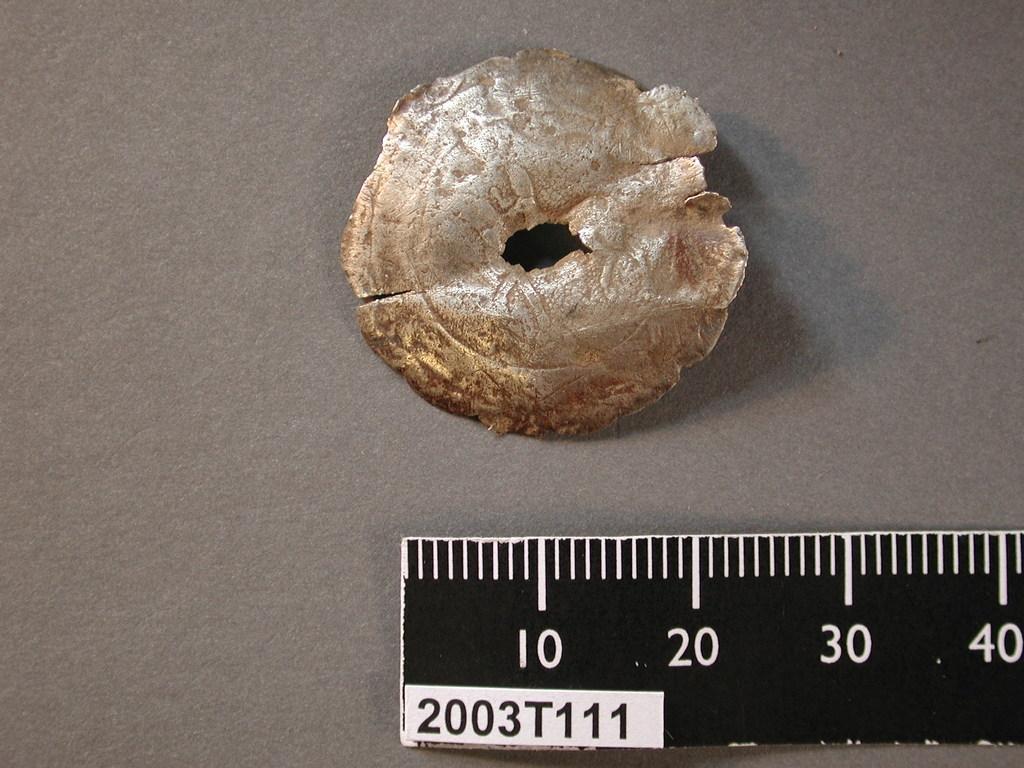In one or two sentences, can you explain what this image depicts? In this image we can see a piece of metal and a scale placed on the surface. 